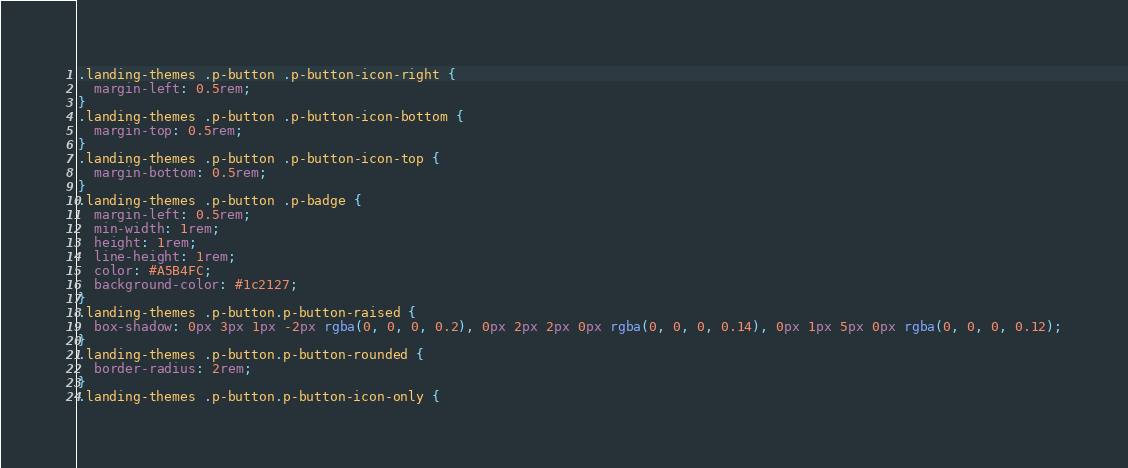<code> <loc_0><loc_0><loc_500><loc_500><_CSS_>.landing-themes .p-button .p-button-icon-right {
  margin-left: 0.5rem;
}
.landing-themes .p-button .p-button-icon-bottom {
  margin-top: 0.5rem;
}
.landing-themes .p-button .p-button-icon-top {
  margin-bottom: 0.5rem;
}
.landing-themes .p-button .p-badge {
  margin-left: 0.5rem;
  min-width: 1rem;
  height: 1rem;
  line-height: 1rem;
  color: #A5B4FC;
  background-color: #1c2127;
}
.landing-themes .p-button.p-button-raised {
  box-shadow: 0px 3px 1px -2px rgba(0, 0, 0, 0.2), 0px 2px 2px 0px rgba(0, 0, 0, 0.14), 0px 1px 5px 0px rgba(0, 0, 0, 0.12);
}
.landing-themes .p-button.p-button-rounded {
  border-radius: 2rem;
}
.landing-themes .p-button.p-button-icon-only {</code> 